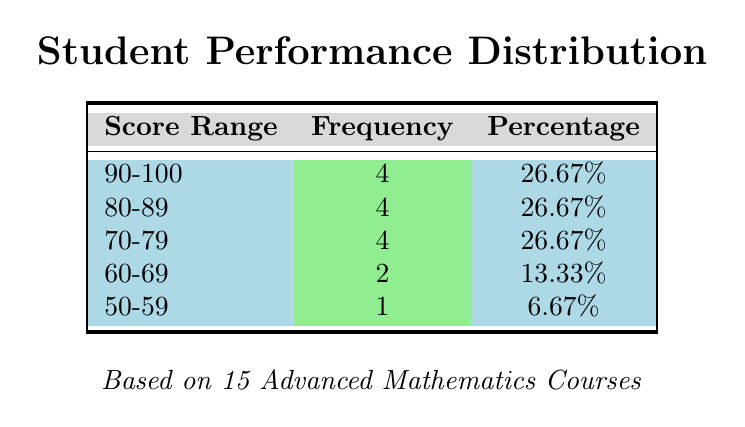What is the highest score range in the distribution? The highest score range in the distribution is determined by comparing the score ranges listed in the table. The score ranges shown are 90-100, 80-89, 70-79, 60-69, and 50-59. The range with the highest minimum value is 90-100.
Answer: 90-100 How many students scored in the 60-69 range? The frequency for the score range 60-69 is directly indicated in the table. It shows that there are 2 students whose scores fall within this range.
Answer: 2 What is the total percentage of students scoring above 80? To find the total percentage of students scoring above 80, we need to add the percentages of the ranges 90-100 and 80-89. From the table, the percentages are 26.67% (90-100) and 26.67% (80-89). So, 26.67% + 26.67% = 53.34%.
Answer: 53.34% Is it true that more than half of the students scored below 70? To determine if this statement is true, we need to find the total frequency of students scoring below 70. The score ranges below 70 are 60-69 (2 students) and 50-59 (1 student), totaling 3 students. The total number of students is 15. Since 3 is less than half of 15, this statement is false.
Answer: False What is the average score of students in the 80-89 range? The average score can be contextualized by identifying the scores represented in the 80-89 range. The score range includes potential scores like 81, 82, 83, 84, 85, 86, 87, 88, and 89. Given that we have 4 students in this range, assuming a midpoint estimate of 84, we calculate the average by multiplying by the number (4), giving us a conceptual average score of 84, representing students performing well between the indicated scores. This average can be validated if we had specific values but is contextual based on frequency.
Answer: 84 